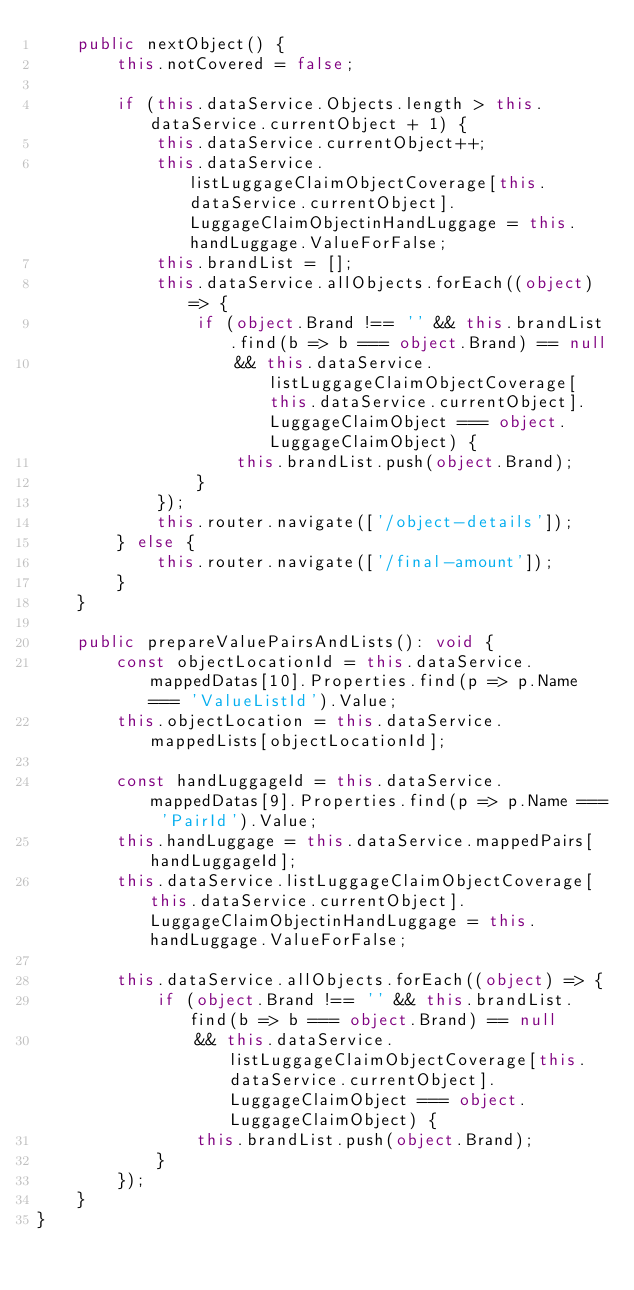<code> <loc_0><loc_0><loc_500><loc_500><_TypeScript_>    public nextObject() {
        this.notCovered = false;

        if (this.dataService.Objects.length > this.dataService.currentObject + 1) {
            this.dataService.currentObject++;
            this.dataService.listLuggageClaimObjectCoverage[this.dataService.currentObject].LuggageClaimObjectinHandLuggage = this.handLuggage.ValueForFalse;
            this.brandList = [];
            this.dataService.allObjects.forEach((object) => {
                if (object.Brand !== '' && this.brandList.find(b => b === object.Brand) == null
                    && this.dataService.listLuggageClaimObjectCoverage[this.dataService.currentObject].LuggageClaimObject === object.LuggageClaimObject) {
                    this.brandList.push(object.Brand);
                }
            });
            this.router.navigate(['/object-details']);
        } else {
            this.router.navigate(['/final-amount']);
        }
    }

    public prepareValuePairsAndLists(): void {
        const objectLocationId = this.dataService.mappedDatas[10].Properties.find(p => p.Name === 'ValueListId').Value;
        this.objectLocation = this.dataService.mappedLists[objectLocationId];

        const handLuggageId = this.dataService.mappedDatas[9].Properties.find(p => p.Name === 'PairId').Value;
        this.handLuggage = this.dataService.mappedPairs[handLuggageId];
        this.dataService.listLuggageClaimObjectCoverage[this.dataService.currentObject].LuggageClaimObjectinHandLuggage = this.handLuggage.ValueForFalse;

        this.dataService.allObjects.forEach((object) => {
            if (object.Brand !== '' && this.brandList.find(b => b === object.Brand) == null
                && this.dataService.listLuggageClaimObjectCoverage[this.dataService.currentObject].LuggageClaimObject === object.LuggageClaimObject) {
                this.brandList.push(object.Brand);
            }
        });
    }
}


</code> 